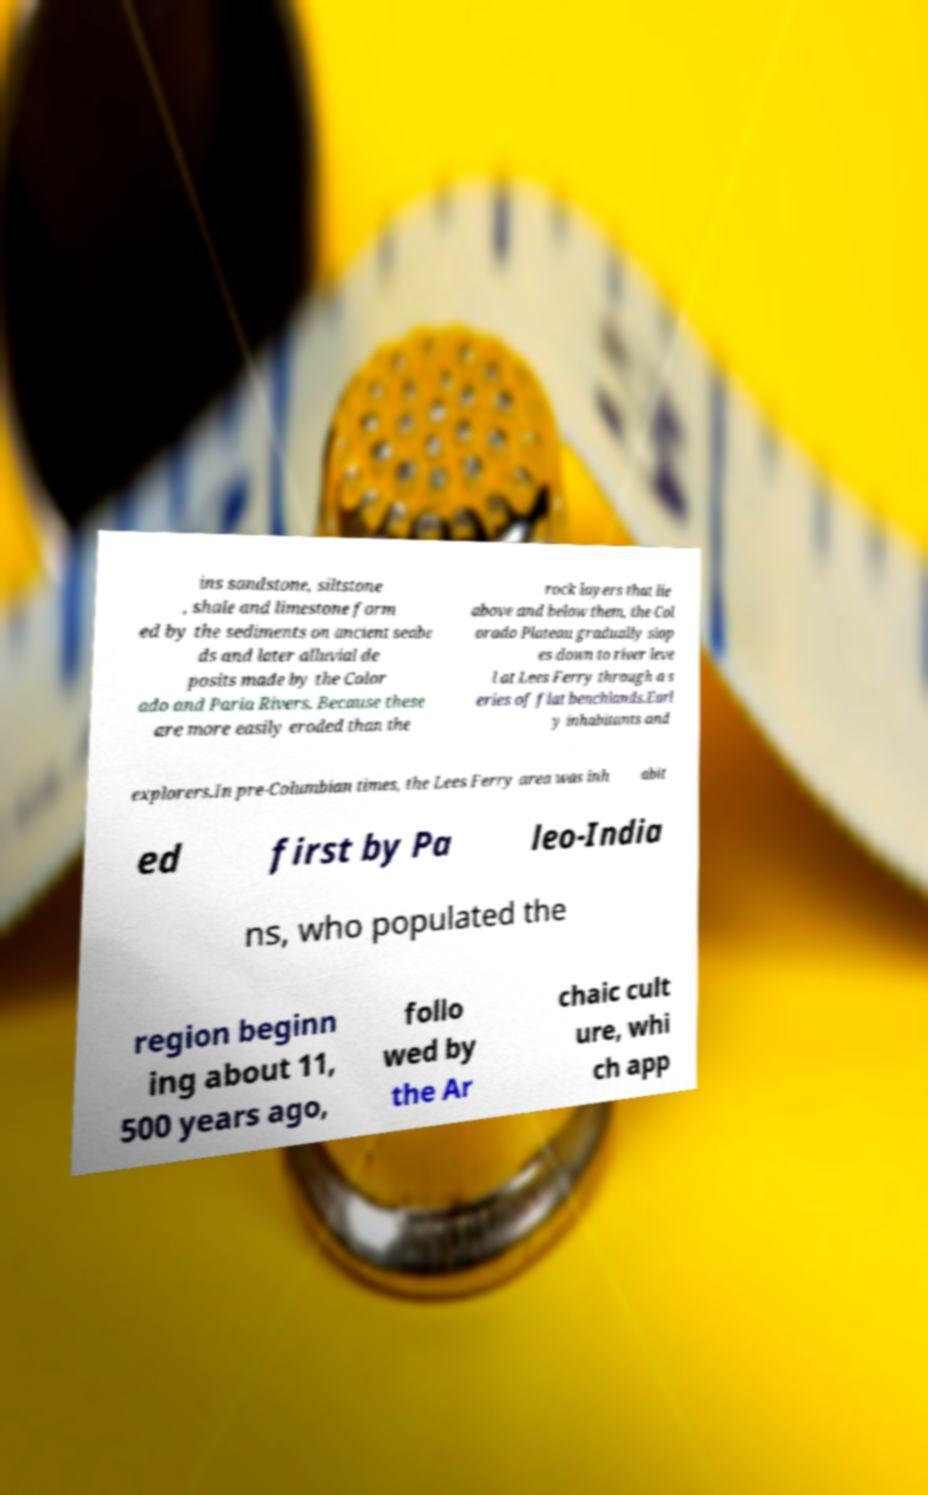I need the written content from this picture converted into text. Can you do that? ins sandstone, siltstone , shale and limestone form ed by the sediments on ancient seabe ds and later alluvial de posits made by the Color ado and Paria Rivers. Because these are more easily eroded than the rock layers that lie above and below them, the Col orado Plateau gradually slop es down to river leve l at Lees Ferry through a s eries of flat benchlands.Earl y inhabitants and explorers.In pre-Columbian times, the Lees Ferry area was inh abit ed first by Pa leo-India ns, who populated the region beginn ing about 11, 500 years ago, follo wed by the Ar chaic cult ure, whi ch app 